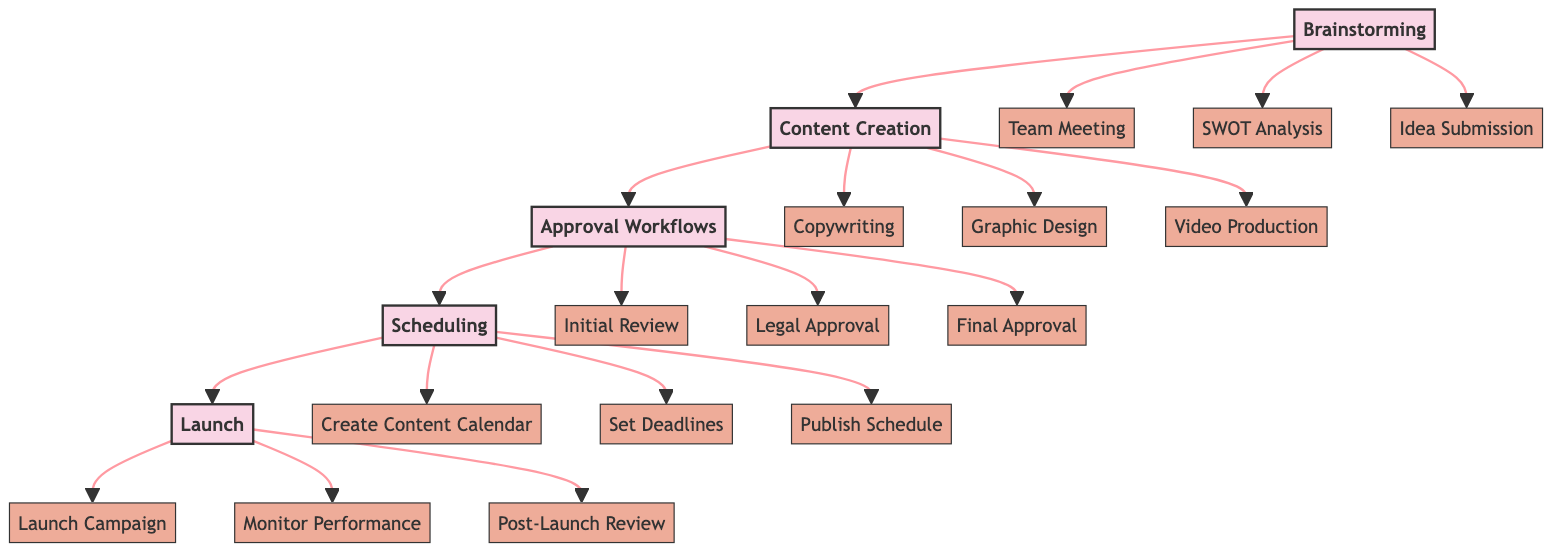What are the first three stages of the campaign planning process? The first three stages are Brainstorming, Content Creation, and Approval Workflows. These stages can be identified by following the arrows from the start of the flowchart.
Answer: Brainstorming, Content Creation, Approval Workflows How many tasks are involved in the Content Creation stage? In the Content Creation stage, there are three tasks: Copywriting, Graphic Design, and Video Production. This can be reasoned by counting the tasks listed under the Content Creation node.
Answer: 3 Who is responsible for the "Final Approval" task? The task of "Final Approval" is listed under the Approval Workflows stage and is marked as being the responsibility of the Executive Team. This can be found by examining the connection from Approval Workflows to its specific tasks.
Answer: Executive Team What is the last stage before the Launch stage? The last stage before Launch is Scheduling. This can be determined by following the flow from the Scheduling node which directly connects to the Launch node.
Answer: Scheduling Which team is responsible for the "Monitor Performance" task? The "Monitor Performance" task falls under the Launch stage and is assigned to the Analytics Team. This can be identified by checking the tasks listed under the Launch stage.
Answer: Analytics Team How many tasks are there in the Scheduling stage? There are three tasks in the Scheduling stage: Create Content Calendar, Set Deadlines, and Publish Schedule, which should be counted from the tasks listed directly under Scheduling.
Answer: 3 What is the relationship between Content Creation and Approval Workflows? The relationship is that Content Creation is directly followed by Approval Workflows, indicating that content created must go through approval before moving on to the next stage. This is observed in the flow from the Content Creation node to the Approval Workflows node.
Answer: Directly follows What stage involves generating and collecting ideas for the campaign? The stage responsible for generating and collecting ideas is Brainstorming. This is explicitly stated in the description of the Brainstorming stage in the diagram.
Answer: Brainstorming 